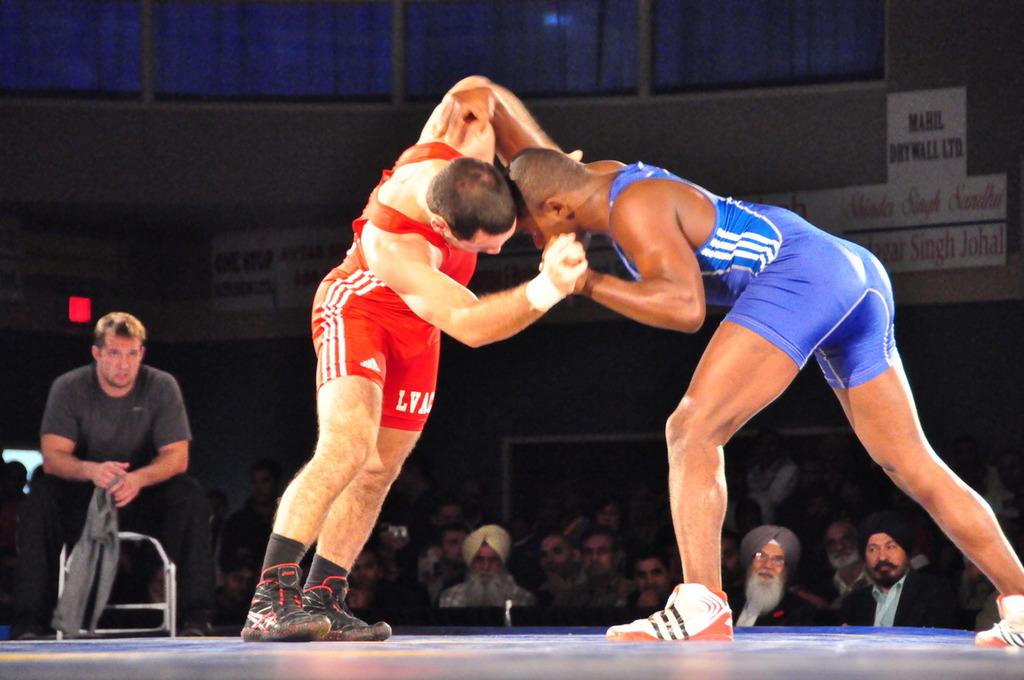What is the team name?
Your answer should be very brief. Unanswerable. What is the brand of red shorts?
Your answer should be very brief. Adidas. 